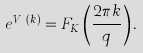<formula> <loc_0><loc_0><loc_500><loc_500>e ^ { V _ { K } ( k ) } = F _ { K } \left ( \frac { 2 \pi k } { q } \right ) .</formula> 